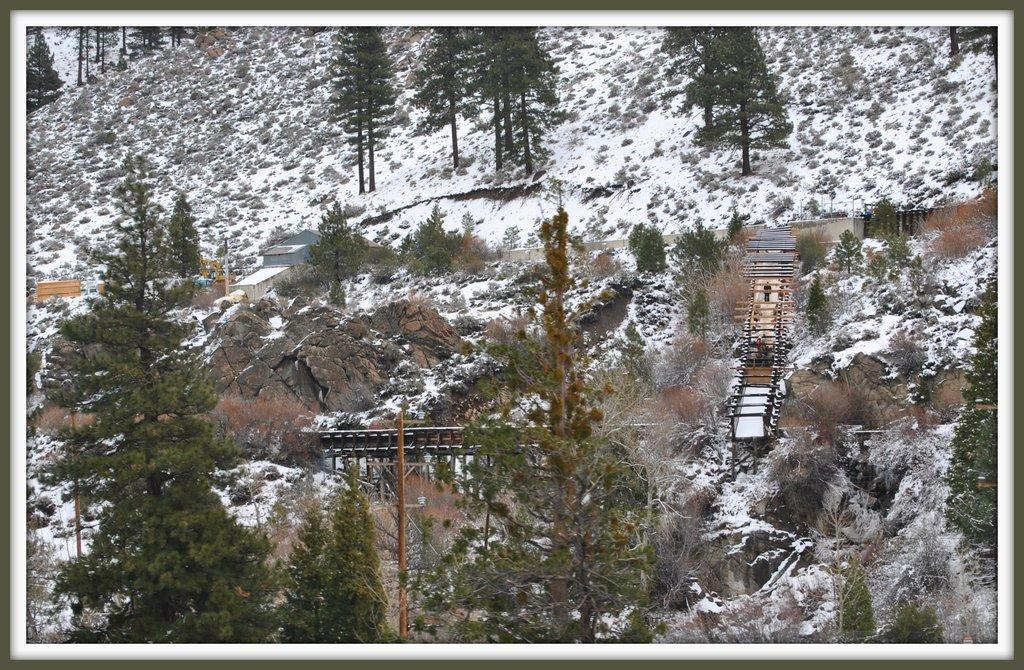What type of natural elements can be seen in the image? There are trees in the image. What type of man-made structures are present in the image? A: There are bridges and buildings in the image. What type of terrain is visible in the image? The ground is covered with snow and grass. What other natural elements can be seen in the image? There are rocks in the image. Can you see a man pushing a carriage near the stove in the image? There is no man, carriage, or stove present in the image. 